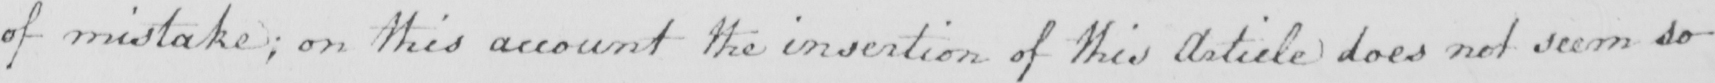Transcribe the text shown in this historical manuscript line. of mistakes ; on this account the insertion of this article does not seem so 